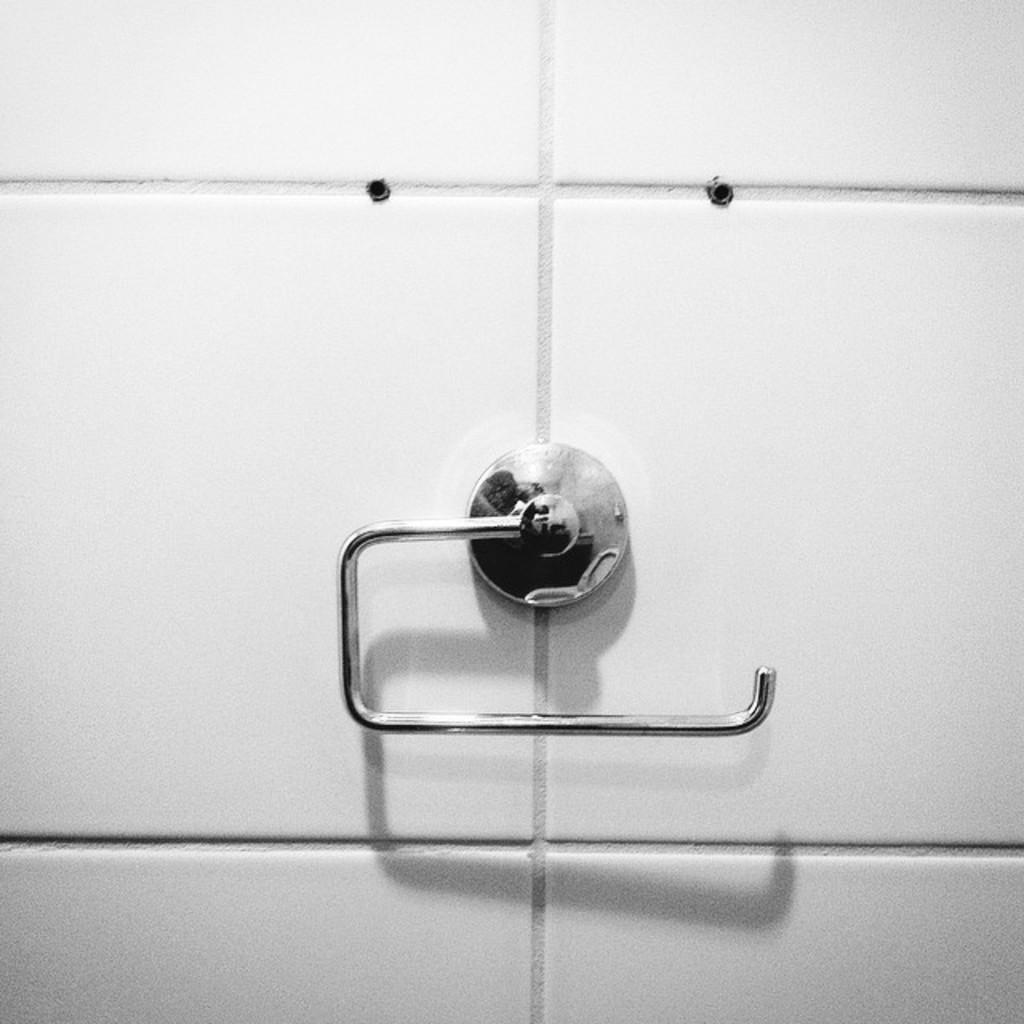Could you give a brief overview of what you see in this image? In the picture I can see the stainless steel towel stand on the wall. 